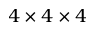<formula> <loc_0><loc_0><loc_500><loc_500>4 \times 4 \times 4</formula> 